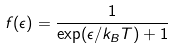Convert formula to latex. <formula><loc_0><loc_0><loc_500><loc_500>f ( \epsilon ) = \frac { 1 } { \exp ( \epsilon / k _ { B } T ) + 1 }</formula> 